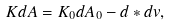<formula> <loc_0><loc_0><loc_500><loc_500>K d A = K _ { 0 } d A _ { 0 } - d \ast d v ,</formula> 